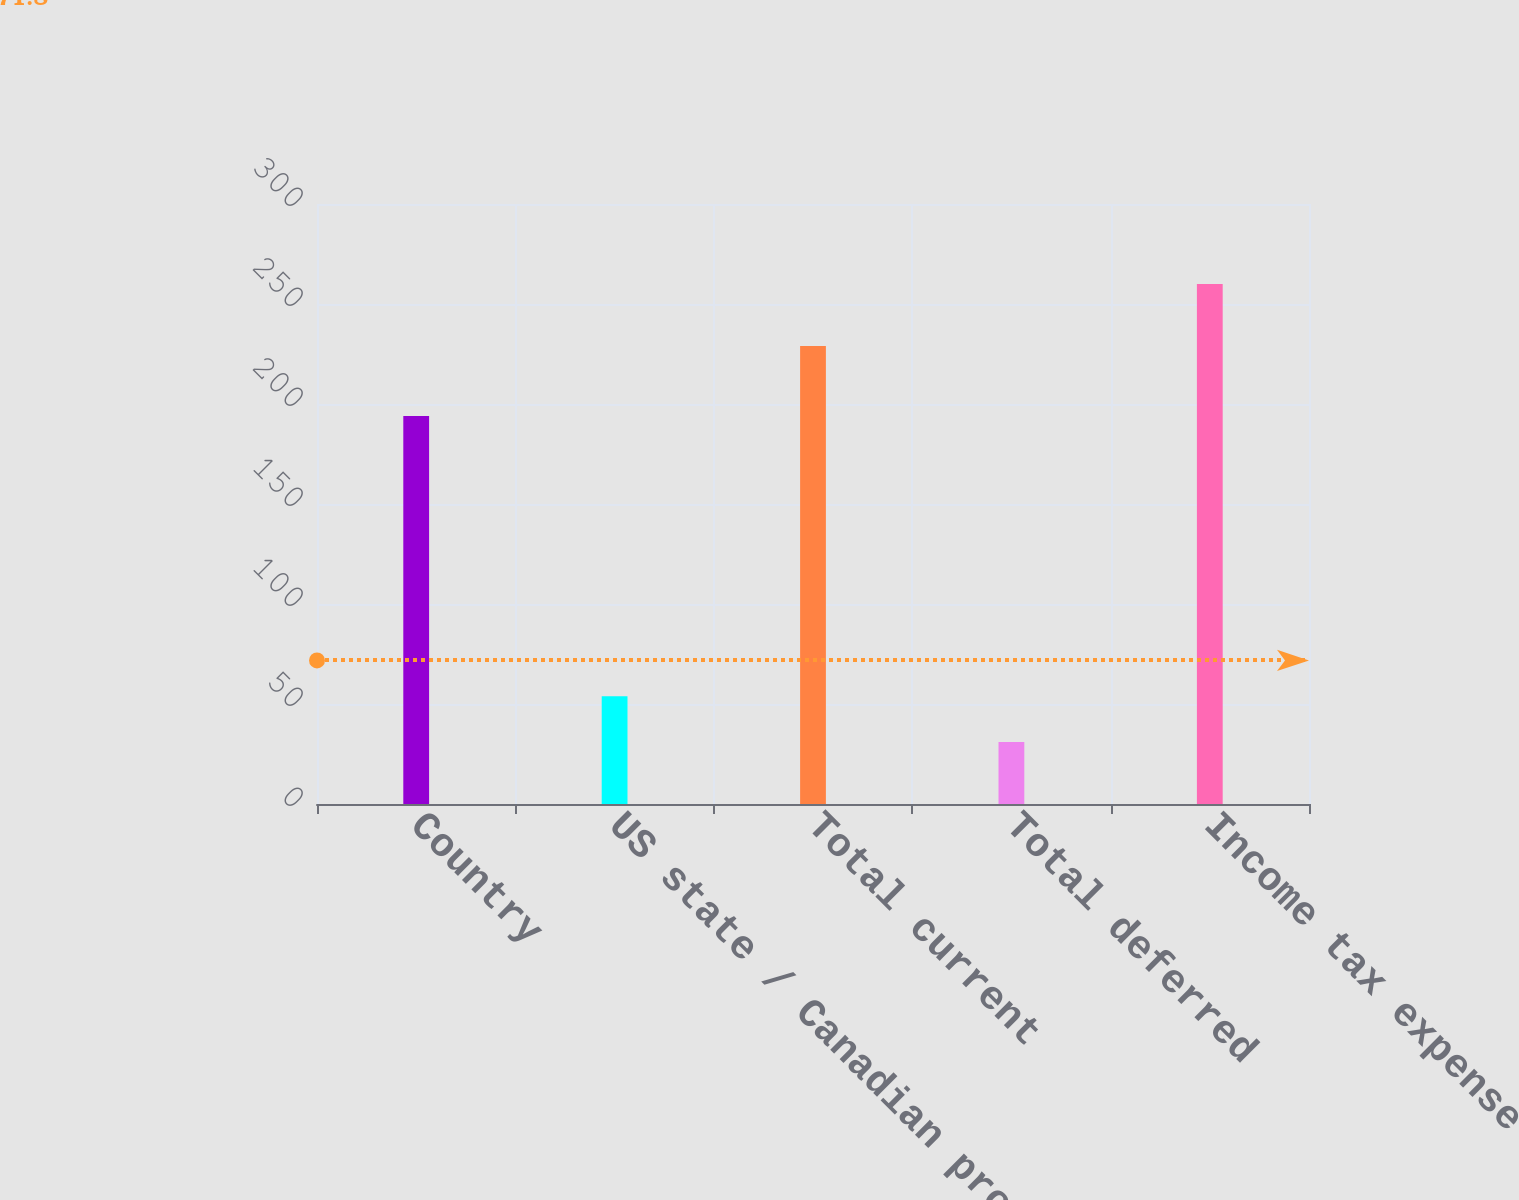Convert chart to OTSL. <chart><loc_0><loc_0><loc_500><loc_500><bar_chart><fcel>Country<fcel>US state / Canadian provincial<fcel>Total current<fcel>Total deferred<fcel>Income tax expense<nl><fcel>194<fcel>53.9<fcel>229<fcel>31<fcel>260<nl></chart> 